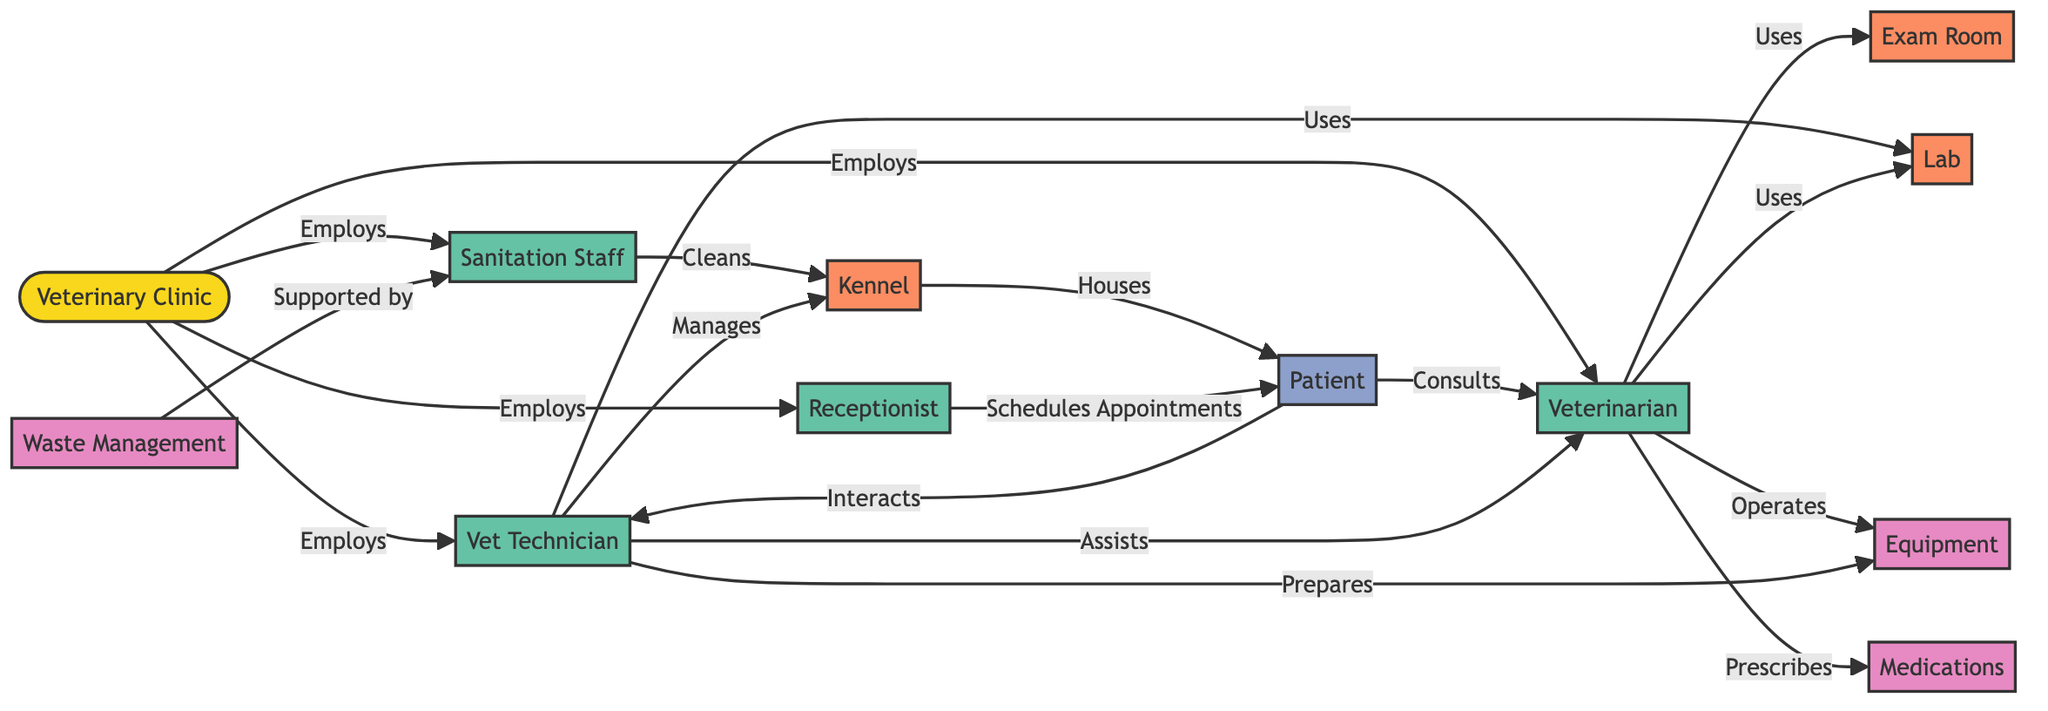What is the role of the veterinarian in relation to the patient? The veterinarian consults with the patient, indicating a direct relationship where the patient seeks advice and treatment from the veterinarian.
Answer: Consults Who manages the kennel? The vet technician is indicated in the diagram as the one who manages the kennel, showing their responsibility for overseeing the area where patients are housed.
Answer: Vet Technician How many staff roles are defined in the diagram? There are four staff roles listed: Veterinarian, Vet Technician, Receptionist, and Sanitation Staff, making a total of four distinct roles.
Answer: 4 Which facility does the veterinarian primarily use for exams? The exam room is identified in the diagram as the facility used primarily by the veterinarian for examining patients.
Answer: Exam Room What resource is used by the veterinarian for prescribing treatments? Medications are directly linked to the veterinarian's role in the diagram, showing that this is the resource they prescribe for patients.
Answer: Medications What interaction occurs between the vet technician and the veterinarian? The vet technician assists the veterinarian, indicating a collaborative relationship where the vet technician provides support during the veterinarian's work.
Answer: Assists How does the sanitation staff contribute to the kennel's upkeep? The sanitation staff cleans the kennel, indicating their role is crucial in maintaining a hygienic environment for the housed patients.
Answer: Cleans What role does the receptionist have concerning the patient? The receptionist schedules appointments for the patient, showing their task of facilitating the patient's visits to the clinic.
Answer: Schedules Appointments What type of support does waste management receive? The sanitation staff supports waste management, indicating that their efforts play a vital role in proper waste handling within the clinic.
Answer: Supported by 